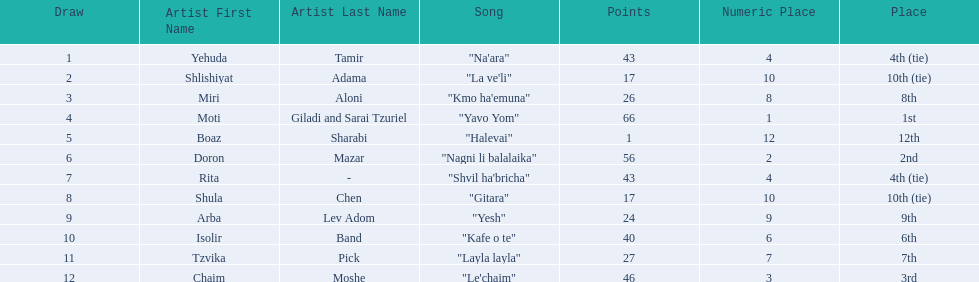What song is listed in the table right before layla layla? "Kafe o te". 